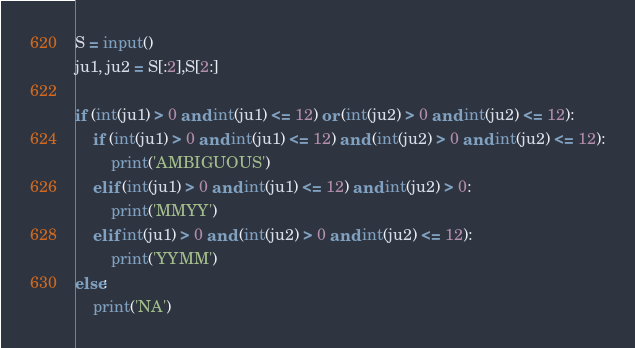Convert code to text. <code><loc_0><loc_0><loc_500><loc_500><_Python_>S = input()
ju1, ju2 = S[:2],S[2:]

if (int(ju1) > 0 and int(ju1) <= 12) or (int(ju2) > 0 and int(ju2) <= 12):
    if (int(ju1) > 0 and int(ju1) <= 12) and (int(ju2) > 0 and int(ju2) <= 12):
        print('AMBIGUOUS')
    elif (int(ju1) > 0 and int(ju1) <= 12) and int(ju2) > 0:
        print('MMYY')
    elif int(ju1) > 0 and (int(ju2) > 0 and int(ju2) <= 12):
        print('YYMM')
else:
    print('NA')</code> 